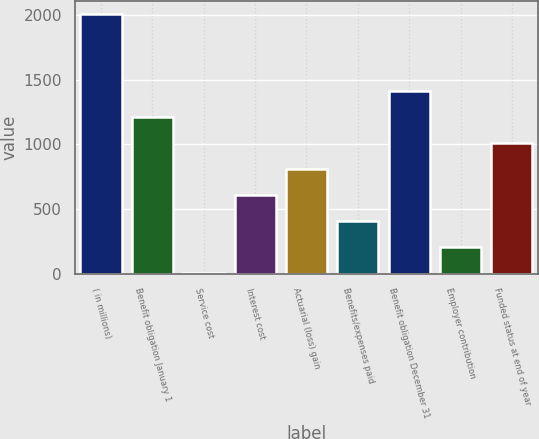<chart> <loc_0><loc_0><loc_500><loc_500><bar_chart><fcel>( in millions)<fcel>Benefit obligation January 1<fcel>Service cost<fcel>Interest cost<fcel>Actuarial (loss) gain<fcel>Benefits/expenses paid<fcel>Benefit obligation December 31<fcel>Employer contribution<fcel>Funded status at end of year<nl><fcel>2010<fcel>1209.44<fcel>8.6<fcel>609.02<fcel>809.16<fcel>408.88<fcel>1409.58<fcel>208.74<fcel>1009.3<nl></chart> 